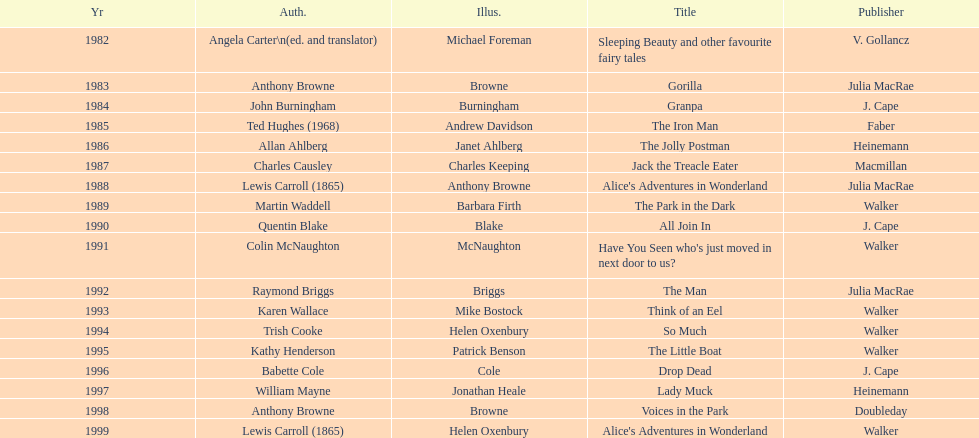Which title was after the year 1991 but before the year 1993? The Man. 